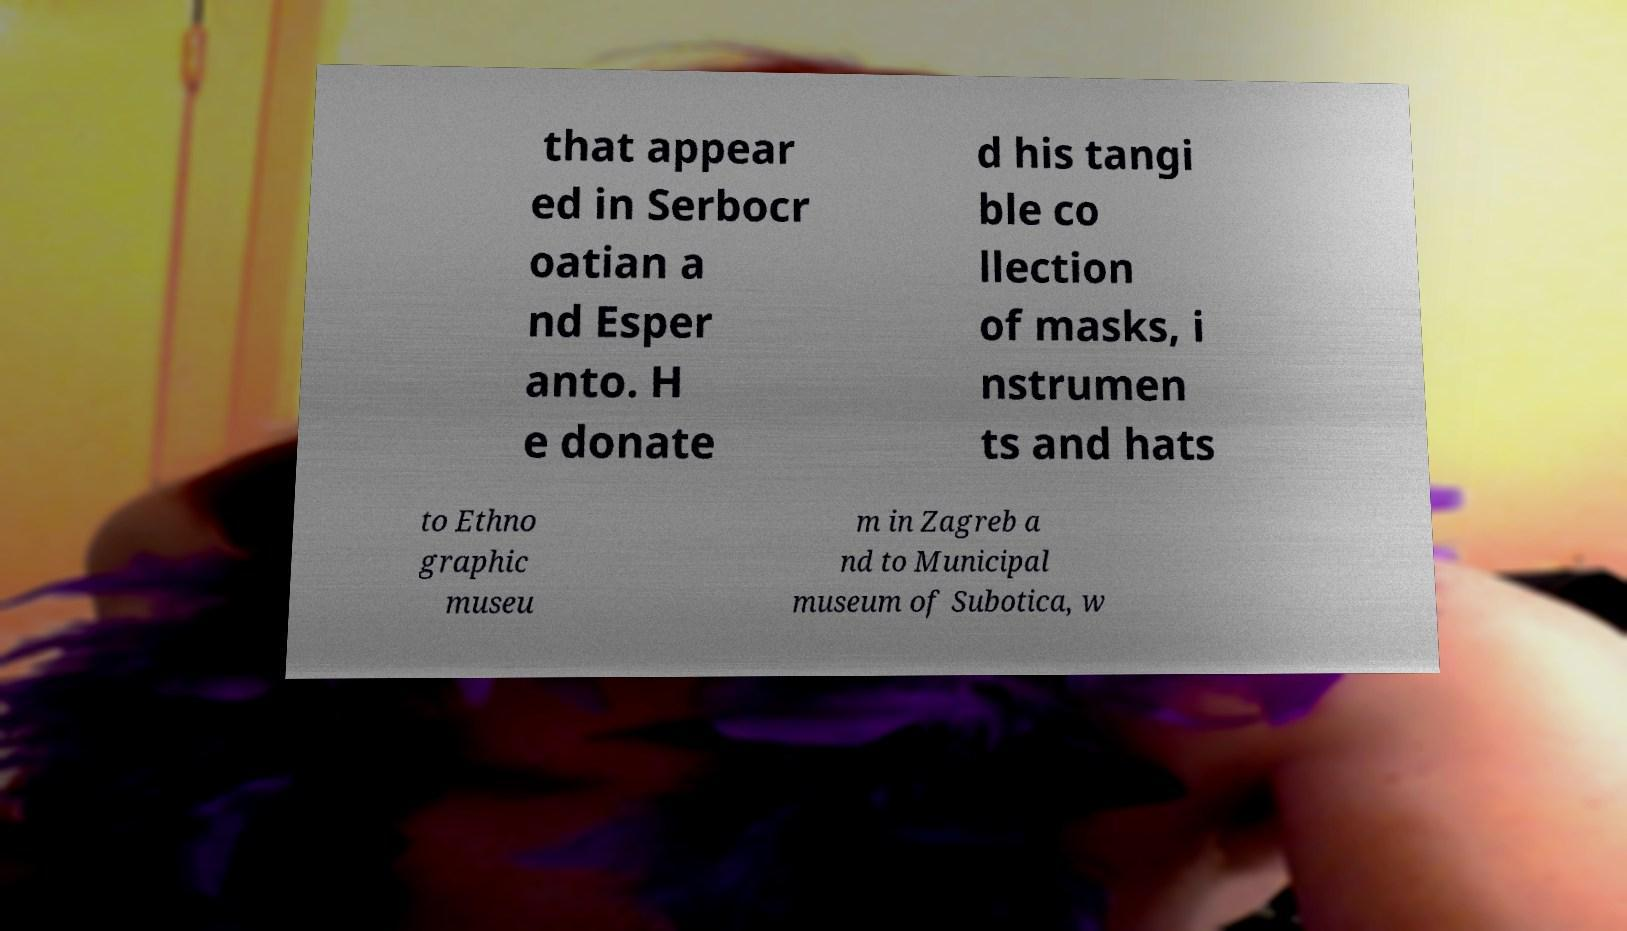There's text embedded in this image that I need extracted. Can you transcribe it verbatim? that appear ed in Serbocr oatian a nd Esper anto. H e donate d his tangi ble co llection of masks, i nstrumen ts and hats to Ethno graphic museu m in Zagreb a nd to Municipal museum of Subotica, w 